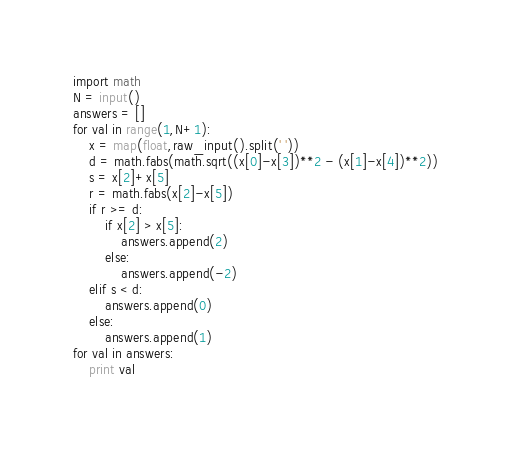<code> <loc_0><loc_0><loc_500><loc_500><_Python_>import math
N = input()
answers = []
for val in range(1,N+1):
	x = map(float,raw_input().split(' '))
	d = math.fabs(math.sqrt((x[0]-x[3])**2 - (x[1]-x[4])**2))
	s = x[2]+x[5]
	r = math.fabs(x[2]-x[5])
	if r >= d:
		if x[2] > x[5]:
			answers.append(2)
		else:
			answers.append(-2)
	elif s < d:
		answers.append(0)
	else:
		answers.append(1)
for val in answers:
	print val</code> 